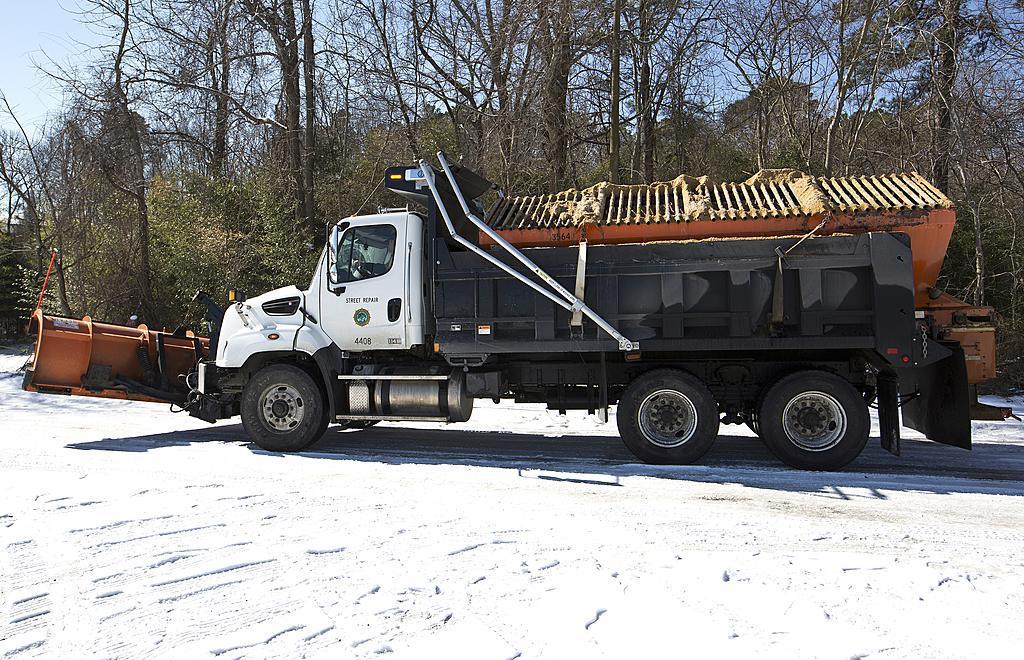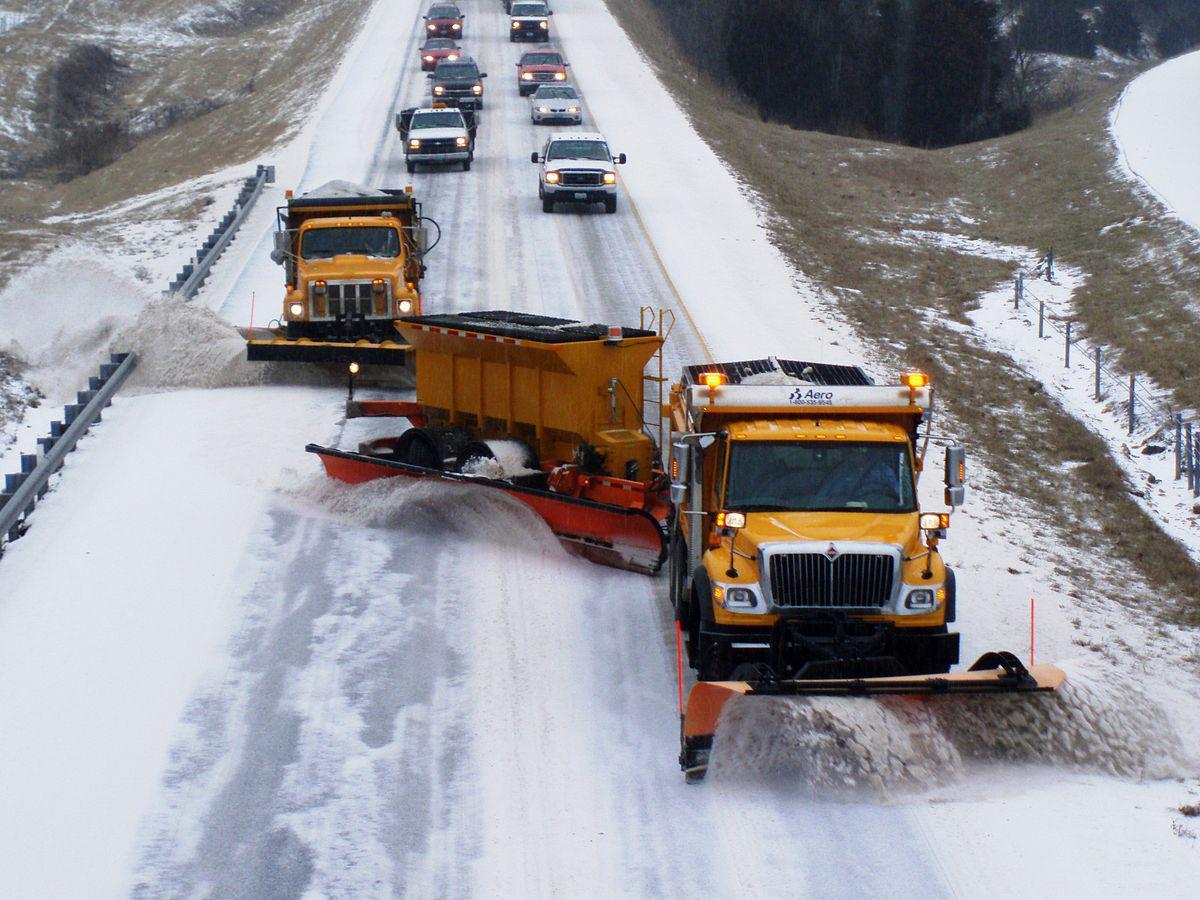The first image is the image on the left, the second image is the image on the right. For the images displayed, is the sentence "Snow cascades off of the plow in the image on the left." factually correct? Answer yes or no. No. 